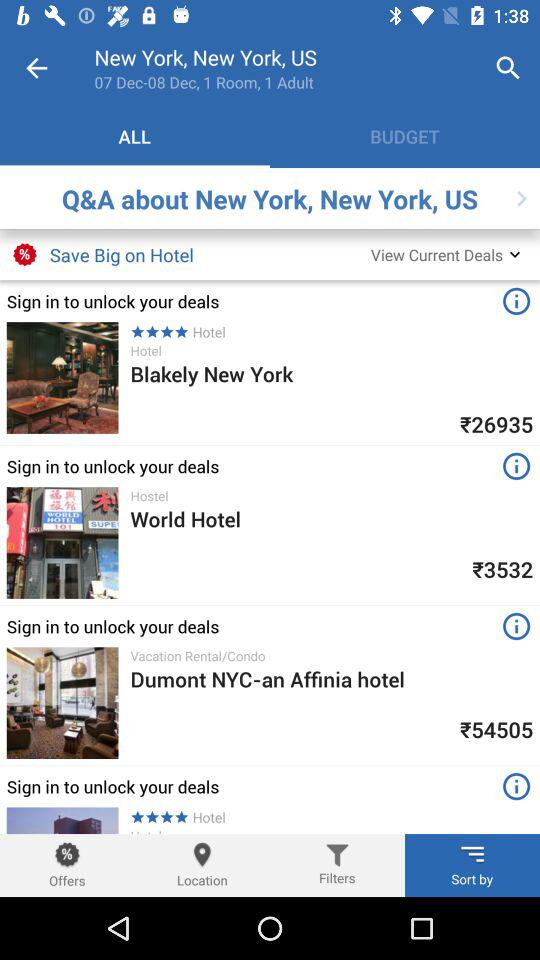How many rooms is the person looking for? The person is looking for 1 room. 